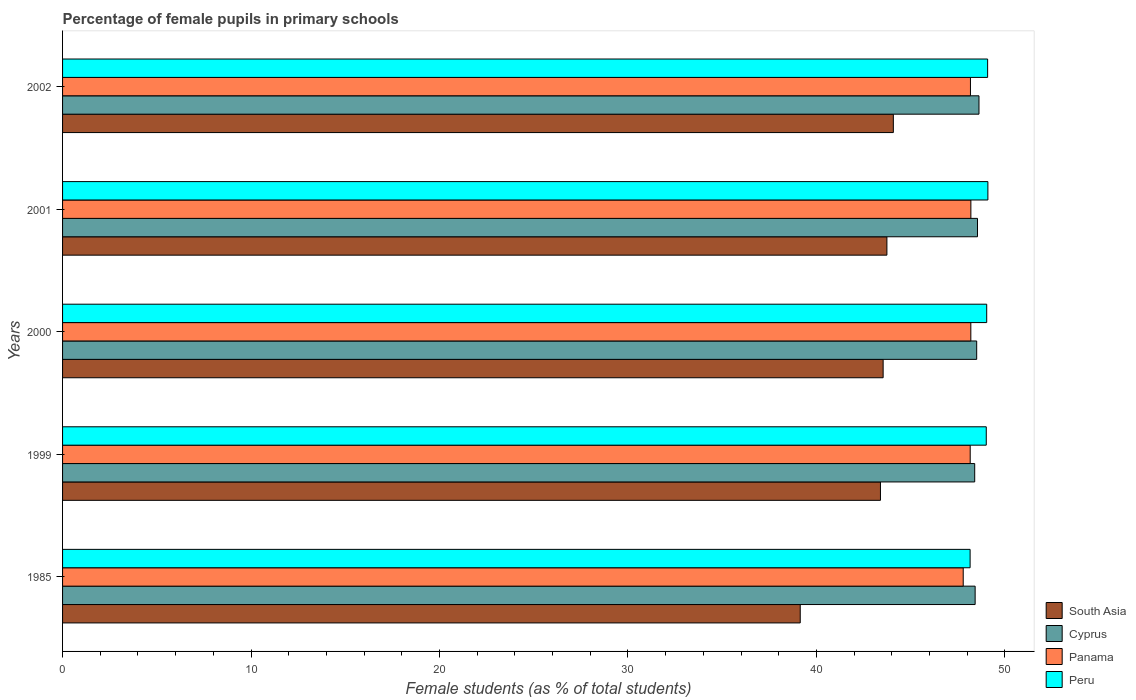Are the number of bars on each tick of the Y-axis equal?
Provide a short and direct response. Yes. How many bars are there on the 1st tick from the top?
Provide a succinct answer. 4. What is the label of the 2nd group of bars from the top?
Provide a short and direct response. 2001. What is the percentage of female pupils in primary schools in Cyprus in 1985?
Your answer should be compact. 48.42. Across all years, what is the maximum percentage of female pupils in primary schools in South Asia?
Provide a short and direct response. 44.08. Across all years, what is the minimum percentage of female pupils in primary schools in Panama?
Provide a short and direct response. 47.79. What is the total percentage of female pupils in primary schools in South Asia in the graph?
Offer a terse response. 213.89. What is the difference between the percentage of female pupils in primary schools in South Asia in 2001 and that in 2002?
Your response must be concise. -0.34. What is the difference between the percentage of female pupils in primary schools in Cyprus in 1985 and the percentage of female pupils in primary schools in Peru in 2001?
Make the answer very short. -0.68. What is the average percentage of female pupils in primary schools in Panama per year?
Keep it short and to the point. 48.1. In the year 1999, what is the difference between the percentage of female pupils in primary schools in Panama and percentage of female pupils in primary schools in South Asia?
Provide a short and direct response. 4.76. In how many years, is the percentage of female pupils in primary schools in Peru greater than 20 %?
Offer a terse response. 5. What is the ratio of the percentage of female pupils in primary schools in Peru in 1985 to that in 1999?
Give a very brief answer. 0.98. What is the difference between the highest and the second highest percentage of female pupils in primary schools in Peru?
Offer a very short reply. 0.01. What is the difference between the highest and the lowest percentage of female pupils in primary schools in Cyprus?
Keep it short and to the point. 0.23. Is it the case that in every year, the sum of the percentage of female pupils in primary schools in South Asia and percentage of female pupils in primary schools in Peru is greater than the sum of percentage of female pupils in primary schools in Cyprus and percentage of female pupils in primary schools in Panama?
Offer a very short reply. Yes. What does the 3rd bar from the top in 1985 represents?
Ensure brevity in your answer.  Cyprus. What does the 3rd bar from the bottom in 2000 represents?
Your response must be concise. Panama. Is it the case that in every year, the sum of the percentage of female pupils in primary schools in Peru and percentage of female pupils in primary schools in South Asia is greater than the percentage of female pupils in primary schools in Cyprus?
Provide a short and direct response. Yes. How many bars are there?
Provide a succinct answer. 20. How many years are there in the graph?
Your response must be concise. 5. What is the difference between two consecutive major ticks on the X-axis?
Your response must be concise. 10. Does the graph contain grids?
Keep it short and to the point. No. Where does the legend appear in the graph?
Make the answer very short. Bottom right. How many legend labels are there?
Offer a terse response. 4. How are the legend labels stacked?
Your answer should be compact. Vertical. What is the title of the graph?
Your answer should be compact. Percentage of female pupils in primary schools. Does "Curacao" appear as one of the legend labels in the graph?
Give a very brief answer. No. What is the label or title of the X-axis?
Keep it short and to the point. Female students (as % of total students). What is the label or title of the Y-axis?
Make the answer very short. Years. What is the Female students (as % of total students) of South Asia in 1985?
Make the answer very short. 39.14. What is the Female students (as % of total students) of Cyprus in 1985?
Ensure brevity in your answer.  48.42. What is the Female students (as % of total students) of Panama in 1985?
Your response must be concise. 47.79. What is the Female students (as % of total students) in Peru in 1985?
Offer a very short reply. 48.15. What is the Female students (as % of total students) of South Asia in 1999?
Your response must be concise. 43.4. What is the Female students (as % of total students) in Cyprus in 1999?
Provide a short and direct response. 48.4. What is the Female students (as % of total students) of Panama in 1999?
Offer a very short reply. 48.16. What is the Female students (as % of total students) of Peru in 1999?
Your answer should be compact. 49.01. What is the Female students (as % of total students) of South Asia in 2000?
Keep it short and to the point. 43.54. What is the Female students (as % of total students) in Cyprus in 2000?
Your answer should be compact. 48.5. What is the Female students (as % of total students) in Panama in 2000?
Ensure brevity in your answer.  48.19. What is the Female students (as % of total students) of Peru in 2000?
Provide a short and direct response. 49.03. What is the Female students (as % of total students) in South Asia in 2001?
Offer a very short reply. 43.74. What is the Female students (as % of total students) in Cyprus in 2001?
Provide a succinct answer. 48.55. What is the Female students (as % of total students) in Panama in 2001?
Make the answer very short. 48.19. What is the Female students (as % of total students) of Peru in 2001?
Ensure brevity in your answer.  49.1. What is the Female students (as % of total students) in South Asia in 2002?
Your answer should be very brief. 44.08. What is the Female students (as % of total students) in Cyprus in 2002?
Keep it short and to the point. 48.62. What is the Female students (as % of total students) of Panama in 2002?
Your answer should be very brief. 48.17. What is the Female students (as % of total students) of Peru in 2002?
Your answer should be very brief. 49.08. Across all years, what is the maximum Female students (as % of total students) in South Asia?
Make the answer very short. 44.08. Across all years, what is the maximum Female students (as % of total students) of Cyprus?
Your answer should be very brief. 48.62. Across all years, what is the maximum Female students (as % of total students) of Panama?
Provide a succinct answer. 48.19. Across all years, what is the maximum Female students (as % of total students) in Peru?
Provide a short and direct response. 49.1. Across all years, what is the minimum Female students (as % of total students) in South Asia?
Give a very brief answer. 39.14. Across all years, what is the minimum Female students (as % of total students) of Cyprus?
Give a very brief answer. 48.4. Across all years, what is the minimum Female students (as % of total students) in Panama?
Provide a short and direct response. 47.79. Across all years, what is the minimum Female students (as % of total students) of Peru?
Offer a terse response. 48.15. What is the total Female students (as % of total students) of South Asia in the graph?
Your response must be concise. 213.89. What is the total Female students (as % of total students) of Cyprus in the graph?
Offer a very short reply. 242.49. What is the total Female students (as % of total students) in Panama in the graph?
Your response must be concise. 240.5. What is the total Female students (as % of total students) in Peru in the graph?
Your answer should be very brief. 244.38. What is the difference between the Female students (as % of total students) of South Asia in 1985 and that in 1999?
Ensure brevity in your answer.  -4.26. What is the difference between the Female students (as % of total students) in Cyprus in 1985 and that in 1999?
Ensure brevity in your answer.  0.02. What is the difference between the Female students (as % of total students) in Panama in 1985 and that in 1999?
Keep it short and to the point. -0.37. What is the difference between the Female students (as % of total students) of Peru in 1985 and that in 1999?
Ensure brevity in your answer.  -0.86. What is the difference between the Female students (as % of total students) in South Asia in 1985 and that in 2000?
Keep it short and to the point. -4.4. What is the difference between the Female students (as % of total students) of Cyprus in 1985 and that in 2000?
Your answer should be very brief. -0.08. What is the difference between the Female students (as % of total students) in Panama in 1985 and that in 2000?
Ensure brevity in your answer.  -0.4. What is the difference between the Female students (as % of total students) of Peru in 1985 and that in 2000?
Offer a very short reply. -0.88. What is the difference between the Female students (as % of total students) in South Asia in 1985 and that in 2001?
Offer a very short reply. -4.6. What is the difference between the Female students (as % of total students) of Cyprus in 1985 and that in 2001?
Keep it short and to the point. -0.13. What is the difference between the Female students (as % of total students) in Panama in 1985 and that in 2001?
Keep it short and to the point. -0.41. What is the difference between the Female students (as % of total students) in Peru in 1985 and that in 2001?
Offer a very short reply. -0.94. What is the difference between the Female students (as % of total students) in South Asia in 1985 and that in 2002?
Offer a terse response. -4.94. What is the difference between the Female students (as % of total students) of Cyprus in 1985 and that in 2002?
Provide a succinct answer. -0.2. What is the difference between the Female students (as % of total students) of Panama in 1985 and that in 2002?
Offer a very short reply. -0.38. What is the difference between the Female students (as % of total students) in Peru in 1985 and that in 2002?
Your answer should be very brief. -0.93. What is the difference between the Female students (as % of total students) of South Asia in 1999 and that in 2000?
Provide a short and direct response. -0.14. What is the difference between the Female students (as % of total students) of Cyprus in 1999 and that in 2000?
Offer a terse response. -0.11. What is the difference between the Female students (as % of total students) of Panama in 1999 and that in 2000?
Provide a short and direct response. -0.03. What is the difference between the Female students (as % of total students) in Peru in 1999 and that in 2000?
Your answer should be very brief. -0.02. What is the difference between the Female students (as % of total students) of South Asia in 1999 and that in 2001?
Offer a terse response. -0.34. What is the difference between the Female students (as % of total students) in Cyprus in 1999 and that in 2001?
Ensure brevity in your answer.  -0.15. What is the difference between the Female students (as % of total students) of Panama in 1999 and that in 2001?
Provide a short and direct response. -0.04. What is the difference between the Female students (as % of total students) in Peru in 1999 and that in 2001?
Your answer should be very brief. -0.09. What is the difference between the Female students (as % of total students) in South Asia in 1999 and that in 2002?
Your response must be concise. -0.68. What is the difference between the Female students (as % of total students) of Cyprus in 1999 and that in 2002?
Your answer should be compact. -0.23. What is the difference between the Female students (as % of total students) in Panama in 1999 and that in 2002?
Your answer should be very brief. -0.01. What is the difference between the Female students (as % of total students) in Peru in 1999 and that in 2002?
Your answer should be very brief. -0.07. What is the difference between the Female students (as % of total students) of South Asia in 2000 and that in 2001?
Your answer should be compact. -0.2. What is the difference between the Female students (as % of total students) of Cyprus in 2000 and that in 2001?
Provide a succinct answer. -0.04. What is the difference between the Female students (as % of total students) of Panama in 2000 and that in 2001?
Offer a very short reply. -0. What is the difference between the Female students (as % of total students) of Peru in 2000 and that in 2001?
Ensure brevity in your answer.  -0.06. What is the difference between the Female students (as % of total students) of South Asia in 2000 and that in 2002?
Provide a short and direct response. -0.54. What is the difference between the Female students (as % of total students) in Cyprus in 2000 and that in 2002?
Offer a very short reply. -0.12. What is the difference between the Female students (as % of total students) of Panama in 2000 and that in 2002?
Provide a short and direct response. 0.02. What is the difference between the Female students (as % of total students) of Peru in 2000 and that in 2002?
Provide a succinct answer. -0.05. What is the difference between the Female students (as % of total students) in South Asia in 2001 and that in 2002?
Provide a short and direct response. -0.34. What is the difference between the Female students (as % of total students) of Cyprus in 2001 and that in 2002?
Offer a very short reply. -0.08. What is the difference between the Female students (as % of total students) of Panama in 2001 and that in 2002?
Ensure brevity in your answer.  0.02. What is the difference between the Female students (as % of total students) in Peru in 2001 and that in 2002?
Ensure brevity in your answer.  0.01. What is the difference between the Female students (as % of total students) in South Asia in 1985 and the Female students (as % of total students) in Cyprus in 1999?
Your answer should be very brief. -9.26. What is the difference between the Female students (as % of total students) of South Asia in 1985 and the Female students (as % of total students) of Panama in 1999?
Your answer should be compact. -9.02. What is the difference between the Female students (as % of total students) in South Asia in 1985 and the Female students (as % of total students) in Peru in 1999?
Provide a short and direct response. -9.87. What is the difference between the Female students (as % of total students) of Cyprus in 1985 and the Female students (as % of total students) of Panama in 1999?
Provide a succinct answer. 0.26. What is the difference between the Female students (as % of total students) in Cyprus in 1985 and the Female students (as % of total students) in Peru in 1999?
Keep it short and to the point. -0.59. What is the difference between the Female students (as % of total students) in Panama in 1985 and the Female students (as % of total students) in Peru in 1999?
Your answer should be compact. -1.22. What is the difference between the Female students (as % of total students) in South Asia in 1985 and the Female students (as % of total students) in Cyprus in 2000?
Offer a terse response. -9.36. What is the difference between the Female students (as % of total students) of South Asia in 1985 and the Female students (as % of total students) of Panama in 2000?
Provide a succinct answer. -9.05. What is the difference between the Female students (as % of total students) in South Asia in 1985 and the Female students (as % of total students) in Peru in 2000?
Your answer should be compact. -9.89. What is the difference between the Female students (as % of total students) of Cyprus in 1985 and the Female students (as % of total students) of Panama in 2000?
Offer a terse response. 0.23. What is the difference between the Female students (as % of total students) of Cyprus in 1985 and the Female students (as % of total students) of Peru in 2000?
Offer a very short reply. -0.61. What is the difference between the Female students (as % of total students) of Panama in 1985 and the Female students (as % of total students) of Peru in 2000?
Provide a succinct answer. -1.25. What is the difference between the Female students (as % of total students) of South Asia in 1985 and the Female students (as % of total students) of Cyprus in 2001?
Offer a very short reply. -9.41. What is the difference between the Female students (as % of total students) of South Asia in 1985 and the Female students (as % of total students) of Panama in 2001?
Give a very brief answer. -9.05. What is the difference between the Female students (as % of total students) of South Asia in 1985 and the Female students (as % of total students) of Peru in 2001?
Offer a very short reply. -9.96. What is the difference between the Female students (as % of total students) of Cyprus in 1985 and the Female students (as % of total students) of Panama in 2001?
Provide a short and direct response. 0.23. What is the difference between the Female students (as % of total students) of Cyprus in 1985 and the Female students (as % of total students) of Peru in 2001?
Your answer should be very brief. -0.68. What is the difference between the Female students (as % of total students) of Panama in 1985 and the Female students (as % of total students) of Peru in 2001?
Your answer should be very brief. -1.31. What is the difference between the Female students (as % of total students) of South Asia in 1985 and the Female students (as % of total students) of Cyprus in 2002?
Offer a very short reply. -9.48. What is the difference between the Female students (as % of total students) in South Asia in 1985 and the Female students (as % of total students) in Panama in 2002?
Keep it short and to the point. -9.03. What is the difference between the Female students (as % of total students) of South Asia in 1985 and the Female students (as % of total students) of Peru in 2002?
Keep it short and to the point. -9.94. What is the difference between the Female students (as % of total students) of Cyprus in 1985 and the Female students (as % of total students) of Panama in 2002?
Make the answer very short. 0.25. What is the difference between the Female students (as % of total students) of Cyprus in 1985 and the Female students (as % of total students) of Peru in 2002?
Give a very brief answer. -0.66. What is the difference between the Female students (as % of total students) of Panama in 1985 and the Female students (as % of total students) of Peru in 2002?
Ensure brevity in your answer.  -1.3. What is the difference between the Female students (as % of total students) of South Asia in 1999 and the Female students (as % of total students) of Cyprus in 2000?
Give a very brief answer. -5.11. What is the difference between the Female students (as % of total students) of South Asia in 1999 and the Female students (as % of total students) of Panama in 2000?
Give a very brief answer. -4.8. What is the difference between the Female students (as % of total students) of South Asia in 1999 and the Female students (as % of total students) of Peru in 2000?
Your response must be concise. -5.64. What is the difference between the Female students (as % of total students) of Cyprus in 1999 and the Female students (as % of total students) of Panama in 2000?
Give a very brief answer. 0.21. What is the difference between the Female students (as % of total students) of Cyprus in 1999 and the Female students (as % of total students) of Peru in 2000?
Provide a short and direct response. -0.64. What is the difference between the Female students (as % of total students) in Panama in 1999 and the Female students (as % of total students) in Peru in 2000?
Offer a terse response. -0.88. What is the difference between the Female students (as % of total students) in South Asia in 1999 and the Female students (as % of total students) in Cyprus in 2001?
Make the answer very short. -5.15. What is the difference between the Female students (as % of total students) in South Asia in 1999 and the Female students (as % of total students) in Panama in 2001?
Give a very brief answer. -4.8. What is the difference between the Female students (as % of total students) in South Asia in 1999 and the Female students (as % of total students) in Peru in 2001?
Ensure brevity in your answer.  -5.7. What is the difference between the Female students (as % of total students) of Cyprus in 1999 and the Female students (as % of total students) of Panama in 2001?
Your answer should be compact. 0.2. What is the difference between the Female students (as % of total students) in Cyprus in 1999 and the Female students (as % of total students) in Peru in 2001?
Offer a very short reply. -0.7. What is the difference between the Female students (as % of total students) in Panama in 1999 and the Female students (as % of total students) in Peru in 2001?
Offer a terse response. -0.94. What is the difference between the Female students (as % of total students) of South Asia in 1999 and the Female students (as % of total students) of Cyprus in 2002?
Keep it short and to the point. -5.23. What is the difference between the Female students (as % of total students) in South Asia in 1999 and the Female students (as % of total students) in Panama in 2002?
Offer a terse response. -4.78. What is the difference between the Female students (as % of total students) in South Asia in 1999 and the Female students (as % of total students) in Peru in 2002?
Your answer should be compact. -5.69. What is the difference between the Female students (as % of total students) of Cyprus in 1999 and the Female students (as % of total students) of Panama in 2002?
Your response must be concise. 0.23. What is the difference between the Female students (as % of total students) in Cyprus in 1999 and the Female students (as % of total students) in Peru in 2002?
Offer a very short reply. -0.69. What is the difference between the Female students (as % of total students) of Panama in 1999 and the Female students (as % of total students) of Peru in 2002?
Your answer should be very brief. -0.92. What is the difference between the Female students (as % of total students) of South Asia in 2000 and the Female students (as % of total students) of Cyprus in 2001?
Offer a terse response. -5.01. What is the difference between the Female students (as % of total students) in South Asia in 2000 and the Female students (as % of total students) in Panama in 2001?
Your answer should be very brief. -4.65. What is the difference between the Female students (as % of total students) of South Asia in 2000 and the Female students (as % of total students) of Peru in 2001?
Provide a short and direct response. -5.56. What is the difference between the Female students (as % of total students) of Cyprus in 2000 and the Female students (as % of total students) of Panama in 2001?
Offer a terse response. 0.31. What is the difference between the Female students (as % of total students) of Cyprus in 2000 and the Female students (as % of total students) of Peru in 2001?
Keep it short and to the point. -0.6. What is the difference between the Female students (as % of total students) in Panama in 2000 and the Female students (as % of total students) in Peru in 2001?
Make the answer very short. -0.91. What is the difference between the Female students (as % of total students) of South Asia in 2000 and the Female students (as % of total students) of Cyprus in 2002?
Provide a short and direct response. -5.09. What is the difference between the Female students (as % of total students) of South Asia in 2000 and the Female students (as % of total students) of Panama in 2002?
Give a very brief answer. -4.63. What is the difference between the Female students (as % of total students) in South Asia in 2000 and the Female students (as % of total students) in Peru in 2002?
Make the answer very short. -5.54. What is the difference between the Female students (as % of total students) of Cyprus in 2000 and the Female students (as % of total students) of Panama in 2002?
Provide a succinct answer. 0.33. What is the difference between the Female students (as % of total students) of Cyprus in 2000 and the Female students (as % of total students) of Peru in 2002?
Your response must be concise. -0.58. What is the difference between the Female students (as % of total students) in Panama in 2000 and the Female students (as % of total students) in Peru in 2002?
Offer a terse response. -0.89. What is the difference between the Female students (as % of total students) in South Asia in 2001 and the Female students (as % of total students) in Cyprus in 2002?
Provide a short and direct response. -4.89. What is the difference between the Female students (as % of total students) of South Asia in 2001 and the Female students (as % of total students) of Panama in 2002?
Provide a short and direct response. -4.43. What is the difference between the Female students (as % of total students) in South Asia in 2001 and the Female students (as % of total students) in Peru in 2002?
Keep it short and to the point. -5.34. What is the difference between the Female students (as % of total students) in Cyprus in 2001 and the Female students (as % of total students) in Panama in 2002?
Provide a short and direct response. 0.37. What is the difference between the Female students (as % of total students) in Cyprus in 2001 and the Female students (as % of total students) in Peru in 2002?
Provide a succinct answer. -0.54. What is the difference between the Female students (as % of total students) in Panama in 2001 and the Female students (as % of total students) in Peru in 2002?
Ensure brevity in your answer.  -0.89. What is the average Female students (as % of total students) in South Asia per year?
Keep it short and to the point. 42.78. What is the average Female students (as % of total students) of Cyprus per year?
Keep it short and to the point. 48.5. What is the average Female students (as % of total students) of Panama per year?
Ensure brevity in your answer.  48.1. What is the average Female students (as % of total students) in Peru per year?
Provide a short and direct response. 48.88. In the year 1985, what is the difference between the Female students (as % of total students) in South Asia and Female students (as % of total students) in Cyprus?
Your answer should be compact. -9.28. In the year 1985, what is the difference between the Female students (as % of total students) in South Asia and Female students (as % of total students) in Panama?
Ensure brevity in your answer.  -8.65. In the year 1985, what is the difference between the Female students (as % of total students) in South Asia and Female students (as % of total students) in Peru?
Your response must be concise. -9.01. In the year 1985, what is the difference between the Female students (as % of total students) of Cyprus and Female students (as % of total students) of Panama?
Your answer should be compact. 0.63. In the year 1985, what is the difference between the Female students (as % of total students) in Cyprus and Female students (as % of total students) in Peru?
Offer a terse response. 0.27. In the year 1985, what is the difference between the Female students (as % of total students) in Panama and Female students (as % of total students) in Peru?
Your answer should be compact. -0.37. In the year 1999, what is the difference between the Female students (as % of total students) in South Asia and Female students (as % of total students) in Cyprus?
Your answer should be compact. -5. In the year 1999, what is the difference between the Female students (as % of total students) of South Asia and Female students (as % of total students) of Panama?
Give a very brief answer. -4.76. In the year 1999, what is the difference between the Female students (as % of total students) of South Asia and Female students (as % of total students) of Peru?
Offer a very short reply. -5.61. In the year 1999, what is the difference between the Female students (as % of total students) of Cyprus and Female students (as % of total students) of Panama?
Keep it short and to the point. 0.24. In the year 1999, what is the difference between the Female students (as % of total students) in Cyprus and Female students (as % of total students) in Peru?
Your response must be concise. -0.61. In the year 1999, what is the difference between the Female students (as % of total students) in Panama and Female students (as % of total students) in Peru?
Ensure brevity in your answer.  -0.85. In the year 2000, what is the difference between the Female students (as % of total students) of South Asia and Female students (as % of total students) of Cyprus?
Provide a short and direct response. -4.96. In the year 2000, what is the difference between the Female students (as % of total students) of South Asia and Female students (as % of total students) of Panama?
Your answer should be compact. -4.65. In the year 2000, what is the difference between the Female students (as % of total students) of South Asia and Female students (as % of total students) of Peru?
Your answer should be very brief. -5.5. In the year 2000, what is the difference between the Female students (as % of total students) in Cyprus and Female students (as % of total students) in Panama?
Make the answer very short. 0.31. In the year 2000, what is the difference between the Female students (as % of total students) in Cyprus and Female students (as % of total students) in Peru?
Offer a very short reply. -0.53. In the year 2000, what is the difference between the Female students (as % of total students) in Panama and Female students (as % of total students) in Peru?
Ensure brevity in your answer.  -0.84. In the year 2001, what is the difference between the Female students (as % of total students) in South Asia and Female students (as % of total students) in Cyprus?
Make the answer very short. -4.81. In the year 2001, what is the difference between the Female students (as % of total students) in South Asia and Female students (as % of total students) in Panama?
Make the answer very short. -4.46. In the year 2001, what is the difference between the Female students (as % of total students) in South Asia and Female students (as % of total students) in Peru?
Keep it short and to the point. -5.36. In the year 2001, what is the difference between the Female students (as % of total students) in Cyprus and Female students (as % of total students) in Panama?
Provide a succinct answer. 0.35. In the year 2001, what is the difference between the Female students (as % of total students) in Cyprus and Female students (as % of total students) in Peru?
Your answer should be very brief. -0.55. In the year 2001, what is the difference between the Female students (as % of total students) in Panama and Female students (as % of total students) in Peru?
Provide a short and direct response. -0.9. In the year 2002, what is the difference between the Female students (as % of total students) of South Asia and Female students (as % of total students) of Cyprus?
Make the answer very short. -4.54. In the year 2002, what is the difference between the Female students (as % of total students) in South Asia and Female students (as % of total students) in Panama?
Your answer should be very brief. -4.09. In the year 2002, what is the difference between the Female students (as % of total students) of South Asia and Female students (as % of total students) of Peru?
Ensure brevity in your answer.  -5. In the year 2002, what is the difference between the Female students (as % of total students) of Cyprus and Female students (as % of total students) of Panama?
Offer a very short reply. 0.45. In the year 2002, what is the difference between the Female students (as % of total students) in Cyprus and Female students (as % of total students) in Peru?
Make the answer very short. -0.46. In the year 2002, what is the difference between the Female students (as % of total students) in Panama and Female students (as % of total students) in Peru?
Make the answer very short. -0.91. What is the ratio of the Female students (as % of total students) of South Asia in 1985 to that in 1999?
Offer a terse response. 0.9. What is the ratio of the Female students (as % of total students) of Panama in 1985 to that in 1999?
Your answer should be very brief. 0.99. What is the ratio of the Female students (as % of total students) in Peru in 1985 to that in 1999?
Offer a very short reply. 0.98. What is the ratio of the Female students (as % of total students) in South Asia in 1985 to that in 2000?
Give a very brief answer. 0.9. What is the ratio of the Female students (as % of total students) in Panama in 1985 to that in 2000?
Keep it short and to the point. 0.99. What is the ratio of the Female students (as % of total students) in South Asia in 1985 to that in 2001?
Provide a short and direct response. 0.89. What is the ratio of the Female students (as % of total students) in Cyprus in 1985 to that in 2001?
Give a very brief answer. 1. What is the ratio of the Female students (as % of total students) of Panama in 1985 to that in 2001?
Your answer should be compact. 0.99. What is the ratio of the Female students (as % of total students) of Peru in 1985 to that in 2001?
Ensure brevity in your answer.  0.98. What is the ratio of the Female students (as % of total students) of South Asia in 1985 to that in 2002?
Offer a terse response. 0.89. What is the ratio of the Female students (as % of total students) in Panama in 1985 to that in 2002?
Your response must be concise. 0.99. What is the ratio of the Female students (as % of total students) of Peru in 1985 to that in 2002?
Your answer should be very brief. 0.98. What is the ratio of the Female students (as % of total students) of South Asia in 1999 to that in 2000?
Give a very brief answer. 1. What is the ratio of the Female students (as % of total students) of Cyprus in 1999 to that in 2000?
Your answer should be compact. 1. What is the ratio of the Female students (as % of total students) of Cyprus in 1999 to that in 2001?
Your answer should be compact. 1. What is the ratio of the Female students (as % of total students) in Peru in 1999 to that in 2001?
Offer a terse response. 1. What is the ratio of the Female students (as % of total students) in South Asia in 1999 to that in 2002?
Offer a terse response. 0.98. What is the ratio of the Female students (as % of total students) in Cyprus in 1999 to that in 2002?
Offer a terse response. 1. What is the ratio of the Female students (as % of total students) in Panama in 1999 to that in 2002?
Provide a succinct answer. 1. What is the ratio of the Female students (as % of total students) in Peru in 1999 to that in 2002?
Give a very brief answer. 1. What is the ratio of the Female students (as % of total students) of South Asia in 2000 to that in 2001?
Make the answer very short. 1. What is the ratio of the Female students (as % of total students) in Cyprus in 2000 to that in 2002?
Your answer should be very brief. 1. What is the difference between the highest and the second highest Female students (as % of total students) of South Asia?
Provide a succinct answer. 0.34. What is the difference between the highest and the second highest Female students (as % of total students) of Cyprus?
Give a very brief answer. 0.08. What is the difference between the highest and the second highest Female students (as % of total students) of Panama?
Your answer should be compact. 0. What is the difference between the highest and the second highest Female students (as % of total students) in Peru?
Provide a short and direct response. 0.01. What is the difference between the highest and the lowest Female students (as % of total students) of South Asia?
Your answer should be very brief. 4.94. What is the difference between the highest and the lowest Female students (as % of total students) of Cyprus?
Make the answer very short. 0.23. What is the difference between the highest and the lowest Female students (as % of total students) of Panama?
Keep it short and to the point. 0.41. What is the difference between the highest and the lowest Female students (as % of total students) in Peru?
Provide a succinct answer. 0.94. 